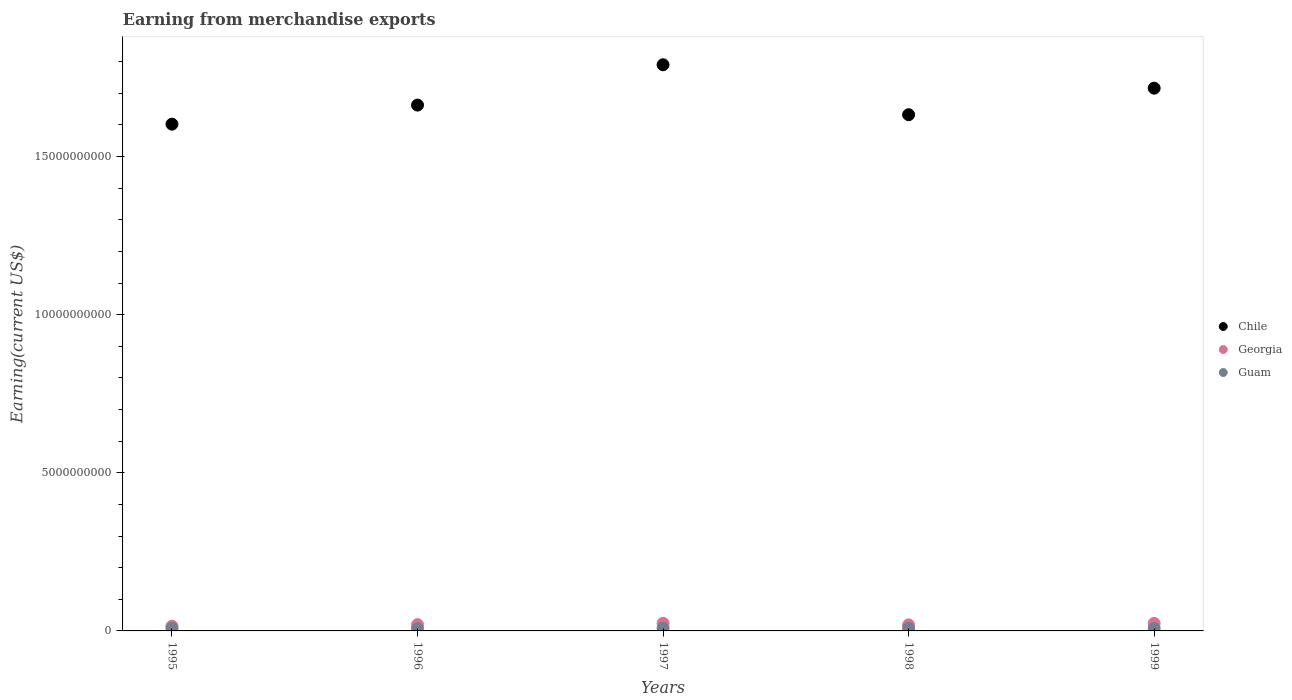What is the amount earned from merchandise exports in Georgia in 1997?
Offer a terse response. 2.40e+08. Across all years, what is the maximum amount earned from merchandise exports in Georgia?
Your answer should be compact. 2.40e+08. Across all years, what is the minimum amount earned from merchandise exports in Guam?
Offer a terse response. 7.32e+07. In which year was the amount earned from merchandise exports in Chile maximum?
Offer a very short reply. 1997. In which year was the amount earned from merchandise exports in Guam minimum?
Provide a short and direct response. 1996. What is the total amount earned from merchandise exports in Chile in the graph?
Give a very brief answer. 8.40e+1. What is the difference between the amount earned from merchandise exports in Chile in 1995 and that in 1999?
Your response must be concise. -1.14e+09. What is the difference between the amount earned from merchandise exports in Guam in 1995 and the amount earned from merchandise exports in Georgia in 1996?
Provide a short and direct response. -1.14e+08. What is the average amount earned from merchandise exports in Georgia per year?
Give a very brief answer. 2.04e+08. In the year 1997, what is the difference between the amount earned from merchandise exports in Guam and amount earned from merchandise exports in Chile?
Make the answer very short. -1.78e+1. In how many years, is the amount earned from merchandise exports in Chile greater than 4000000000 US$?
Provide a short and direct response. 5. What is the ratio of the amount earned from merchandise exports in Chile in 1996 to that in 1997?
Your answer should be very brief. 0.93. What is the difference between the highest and the second highest amount earned from merchandise exports in Guam?
Your answer should be compact. 2.70e+06. What is the difference between the highest and the lowest amount earned from merchandise exports in Guam?
Your response must be concise. 1.55e+07. In how many years, is the amount earned from merchandise exports in Chile greater than the average amount earned from merchandise exports in Chile taken over all years?
Give a very brief answer. 2. Is the sum of the amount earned from merchandise exports in Georgia in 1997 and 1998 greater than the maximum amount earned from merchandise exports in Guam across all years?
Ensure brevity in your answer.  Yes. Is it the case that in every year, the sum of the amount earned from merchandise exports in Georgia and amount earned from merchandise exports in Chile  is greater than the amount earned from merchandise exports in Guam?
Give a very brief answer. Yes. How many years are there in the graph?
Your response must be concise. 5. What is the difference between two consecutive major ticks on the Y-axis?
Offer a terse response. 5.00e+09. Does the graph contain any zero values?
Keep it short and to the point. No. Does the graph contain grids?
Keep it short and to the point. No. How are the legend labels stacked?
Keep it short and to the point. Vertical. What is the title of the graph?
Your answer should be compact. Earning from merchandise exports. Does "Montenegro" appear as one of the legend labels in the graph?
Ensure brevity in your answer.  No. What is the label or title of the Y-axis?
Your response must be concise. Earning(current US$). What is the Earning(current US$) of Chile in 1995?
Make the answer very short. 1.60e+1. What is the Earning(current US$) of Georgia in 1995?
Offer a terse response. 1.51e+08. What is the Earning(current US$) in Guam in 1995?
Your answer should be compact. 8.50e+07. What is the Earning(current US$) of Chile in 1996?
Provide a succinct answer. 1.66e+1. What is the Earning(current US$) in Georgia in 1996?
Provide a short and direct response. 1.99e+08. What is the Earning(current US$) of Guam in 1996?
Provide a short and direct response. 7.32e+07. What is the Earning(current US$) of Chile in 1997?
Make the answer very short. 1.79e+1. What is the Earning(current US$) in Georgia in 1997?
Make the answer very short. 2.40e+08. What is the Earning(current US$) in Guam in 1997?
Provide a short and direct response. 8.87e+07. What is the Earning(current US$) in Chile in 1998?
Offer a very short reply. 1.63e+1. What is the Earning(current US$) in Georgia in 1998?
Your response must be concise. 1.91e+08. What is the Earning(current US$) of Guam in 1998?
Provide a short and direct response. 8.60e+07. What is the Earning(current US$) in Chile in 1999?
Make the answer very short. 1.72e+1. What is the Earning(current US$) of Georgia in 1999?
Your answer should be very brief. 2.38e+08. What is the Earning(current US$) in Guam in 1999?
Make the answer very short. 7.60e+07. Across all years, what is the maximum Earning(current US$) in Chile?
Your response must be concise. 1.79e+1. Across all years, what is the maximum Earning(current US$) of Georgia?
Keep it short and to the point. 2.40e+08. Across all years, what is the maximum Earning(current US$) in Guam?
Offer a terse response. 8.87e+07. Across all years, what is the minimum Earning(current US$) of Chile?
Give a very brief answer. 1.60e+1. Across all years, what is the minimum Earning(current US$) of Georgia?
Your answer should be very brief. 1.51e+08. Across all years, what is the minimum Earning(current US$) in Guam?
Keep it short and to the point. 7.32e+07. What is the total Earning(current US$) of Chile in the graph?
Make the answer very short. 8.40e+1. What is the total Earning(current US$) of Georgia in the graph?
Ensure brevity in your answer.  1.02e+09. What is the total Earning(current US$) in Guam in the graph?
Offer a very short reply. 4.09e+08. What is the difference between the Earning(current US$) of Chile in 1995 and that in 1996?
Provide a short and direct response. -6.03e+08. What is the difference between the Earning(current US$) in Georgia in 1995 and that in 1996?
Your answer should be compact. -4.80e+07. What is the difference between the Earning(current US$) of Guam in 1995 and that in 1996?
Make the answer very short. 1.18e+07. What is the difference between the Earning(current US$) of Chile in 1995 and that in 1997?
Provide a succinct answer. -1.88e+09. What is the difference between the Earning(current US$) of Georgia in 1995 and that in 1997?
Your answer should be very brief. -8.90e+07. What is the difference between the Earning(current US$) in Guam in 1995 and that in 1997?
Offer a very short reply. -3.71e+06. What is the difference between the Earning(current US$) in Chile in 1995 and that in 1998?
Provide a succinct answer. -2.99e+08. What is the difference between the Earning(current US$) of Georgia in 1995 and that in 1998?
Give a very brief answer. -4.00e+07. What is the difference between the Earning(current US$) of Guam in 1995 and that in 1998?
Your answer should be very brief. -1.01e+06. What is the difference between the Earning(current US$) in Chile in 1995 and that in 1999?
Make the answer very short. -1.14e+09. What is the difference between the Earning(current US$) in Georgia in 1995 and that in 1999?
Make the answer very short. -8.70e+07. What is the difference between the Earning(current US$) of Guam in 1995 and that in 1999?
Your answer should be very brief. 8.99e+06. What is the difference between the Earning(current US$) of Chile in 1996 and that in 1997?
Your answer should be very brief. -1.28e+09. What is the difference between the Earning(current US$) of Georgia in 1996 and that in 1997?
Your response must be concise. -4.10e+07. What is the difference between the Earning(current US$) in Guam in 1996 and that in 1997?
Provide a succinct answer. -1.55e+07. What is the difference between the Earning(current US$) of Chile in 1996 and that in 1998?
Give a very brief answer. 3.04e+08. What is the difference between the Earning(current US$) in Georgia in 1996 and that in 1998?
Make the answer very short. 8.00e+06. What is the difference between the Earning(current US$) of Guam in 1996 and that in 1998?
Ensure brevity in your answer.  -1.28e+07. What is the difference between the Earning(current US$) in Chile in 1996 and that in 1999?
Your response must be concise. -5.35e+08. What is the difference between the Earning(current US$) of Georgia in 1996 and that in 1999?
Make the answer very short. -3.90e+07. What is the difference between the Earning(current US$) of Guam in 1996 and that in 1999?
Keep it short and to the point. -2.83e+06. What is the difference between the Earning(current US$) in Chile in 1997 and that in 1998?
Ensure brevity in your answer.  1.58e+09. What is the difference between the Earning(current US$) of Georgia in 1997 and that in 1998?
Ensure brevity in your answer.  4.90e+07. What is the difference between the Earning(current US$) in Guam in 1997 and that in 1998?
Keep it short and to the point. 2.70e+06. What is the difference between the Earning(current US$) in Chile in 1997 and that in 1999?
Offer a very short reply. 7.40e+08. What is the difference between the Earning(current US$) in Georgia in 1997 and that in 1999?
Your answer should be very brief. 2.00e+06. What is the difference between the Earning(current US$) of Guam in 1997 and that in 1999?
Give a very brief answer. 1.27e+07. What is the difference between the Earning(current US$) in Chile in 1998 and that in 1999?
Provide a succinct answer. -8.39e+08. What is the difference between the Earning(current US$) in Georgia in 1998 and that in 1999?
Keep it short and to the point. -4.70e+07. What is the difference between the Earning(current US$) of Guam in 1998 and that in 1999?
Your response must be concise. 1.00e+07. What is the difference between the Earning(current US$) in Chile in 1995 and the Earning(current US$) in Georgia in 1996?
Your answer should be very brief. 1.58e+1. What is the difference between the Earning(current US$) of Chile in 1995 and the Earning(current US$) of Guam in 1996?
Ensure brevity in your answer.  1.60e+1. What is the difference between the Earning(current US$) in Georgia in 1995 and the Earning(current US$) in Guam in 1996?
Keep it short and to the point. 7.78e+07. What is the difference between the Earning(current US$) of Chile in 1995 and the Earning(current US$) of Georgia in 1997?
Ensure brevity in your answer.  1.58e+1. What is the difference between the Earning(current US$) in Chile in 1995 and the Earning(current US$) in Guam in 1997?
Keep it short and to the point. 1.59e+1. What is the difference between the Earning(current US$) in Georgia in 1995 and the Earning(current US$) in Guam in 1997?
Offer a terse response. 6.23e+07. What is the difference between the Earning(current US$) of Chile in 1995 and the Earning(current US$) of Georgia in 1998?
Your answer should be very brief. 1.58e+1. What is the difference between the Earning(current US$) of Chile in 1995 and the Earning(current US$) of Guam in 1998?
Ensure brevity in your answer.  1.59e+1. What is the difference between the Earning(current US$) of Georgia in 1995 and the Earning(current US$) of Guam in 1998?
Provide a short and direct response. 6.50e+07. What is the difference between the Earning(current US$) in Chile in 1995 and the Earning(current US$) in Georgia in 1999?
Make the answer very short. 1.58e+1. What is the difference between the Earning(current US$) in Chile in 1995 and the Earning(current US$) in Guam in 1999?
Offer a very short reply. 1.59e+1. What is the difference between the Earning(current US$) in Georgia in 1995 and the Earning(current US$) in Guam in 1999?
Your answer should be compact. 7.50e+07. What is the difference between the Earning(current US$) in Chile in 1996 and the Earning(current US$) in Georgia in 1997?
Keep it short and to the point. 1.64e+1. What is the difference between the Earning(current US$) in Chile in 1996 and the Earning(current US$) in Guam in 1997?
Your response must be concise. 1.65e+1. What is the difference between the Earning(current US$) in Georgia in 1996 and the Earning(current US$) in Guam in 1997?
Make the answer very short. 1.10e+08. What is the difference between the Earning(current US$) in Chile in 1996 and the Earning(current US$) in Georgia in 1998?
Make the answer very short. 1.64e+1. What is the difference between the Earning(current US$) of Chile in 1996 and the Earning(current US$) of Guam in 1998?
Provide a succinct answer. 1.65e+1. What is the difference between the Earning(current US$) in Georgia in 1996 and the Earning(current US$) in Guam in 1998?
Provide a succinct answer. 1.13e+08. What is the difference between the Earning(current US$) in Chile in 1996 and the Earning(current US$) in Georgia in 1999?
Ensure brevity in your answer.  1.64e+1. What is the difference between the Earning(current US$) of Chile in 1996 and the Earning(current US$) of Guam in 1999?
Your response must be concise. 1.66e+1. What is the difference between the Earning(current US$) in Georgia in 1996 and the Earning(current US$) in Guam in 1999?
Keep it short and to the point. 1.23e+08. What is the difference between the Earning(current US$) in Chile in 1997 and the Earning(current US$) in Georgia in 1998?
Give a very brief answer. 1.77e+1. What is the difference between the Earning(current US$) of Chile in 1997 and the Earning(current US$) of Guam in 1998?
Provide a short and direct response. 1.78e+1. What is the difference between the Earning(current US$) in Georgia in 1997 and the Earning(current US$) in Guam in 1998?
Your answer should be compact. 1.54e+08. What is the difference between the Earning(current US$) in Chile in 1997 and the Earning(current US$) in Georgia in 1999?
Give a very brief answer. 1.77e+1. What is the difference between the Earning(current US$) in Chile in 1997 and the Earning(current US$) in Guam in 1999?
Provide a succinct answer. 1.78e+1. What is the difference between the Earning(current US$) of Georgia in 1997 and the Earning(current US$) of Guam in 1999?
Your answer should be very brief. 1.64e+08. What is the difference between the Earning(current US$) in Chile in 1998 and the Earning(current US$) in Georgia in 1999?
Offer a very short reply. 1.61e+1. What is the difference between the Earning(current US$) in Chile in 1998 and the Earning(current US$) in Guam in 1999?
Provide a short and direct response. 1.62e+1. What is the difference between the Earning(current US$) in Georgia in 1998 and the Earning(current US$) in Guam in 1999?
Your response must be concise. 1.15e+08. What is the average Earning(current US$) in Chile per year?
Provide a succinct answer. 1.68e+1. What is the average Earning(current US$) in Georgia per year?
Your response must be concise. 2.04e+08. What is the average Earning(current US$) in Guam per year?
Give a very brief answer. 8.18e+07. In the year 1995, what is the difference between the Earning(current US$) in Chile and Earning(current US$) in Georgia?
Keep it short and to the point. 1.59e+1. In the year 1995, what is the difference between the Earning(current US$) in Chile and Earning(current US$) in Guam?
Keep it short and to the point. 1.59e+1. In the year 1995, what is the difference between the Earning(current US$) in Georgia and Earning(current US$) in Guam?
Offer a very short reply. 6.60e+07. In the year 1996, what is the difference between the Earning(current US$) of Chile and Earning(current US$) of Georgia?
Provide a succinct answer. 1.64e+1. In the year 1996, what is the difference between the Earning(current US$) of Chile and Earning(current US$) of Guam?
Ensure brevity in your answer.  1.66e+1. In the year 1996, what is the difference between the Earning(current US$) of Georgia and Earning(current US$) of Guam?
Your answer should be very brief. 1.26e+08. In the year 1997, what is the difference between the Earning(current US$) in Chile and Earning(current US$) in Georgia?
Your answer should be very brief. 1.77e+1. In the year 1997, what is the difference between the Earning(current US$) of Chile and Earning(current US$) of Guam?
Provide a succinct answer. 1.78e+1. In the year 1997, what is the difference between the Earning(current US$) of Georgia and Earning(current US$) of Guam?
Your answer should be compact. 1.51e+08. In the year 1998, what is the difference between the Earning(current US$) in Chile and Earning(current US$) in Georgia?
Your response must be concise. 1.61e+1. In the year 1998, what is the difference between the Earning(current US$) of Chile and Earning(current US$) of Guam?
Offer a terse response. 1.62e+1. In the year 1998, what is the difference between the Earning(current US$) of Georgia and Earning(current US$) of Guam?
Your answer should be very brief. 1.05e+08. In the year 1999, what is the difference between the Earning(current US$) of Chile and Earning(current US$) of Georgia?
Your response must be concise. 1.69e+1. In the year 1999, what is the difference between the Earning(current US$) of Chile and Earning(current US$) of Guam?
Provide a short and direct response. 1.71e+1. In the year 1999, what is the difference between the Earning(current US$) in Georgia and Earning(current US$) in Guam?
Your response must be concise. 1.62e+08. What is the ratio of the Earning(current US$) of Chile in 1995 to that in 1996?
Your answer should be compact. 0.96. What is the ratio of the Earning(current US$) in Georgia in 1995 to that in 1996?
Provide a succinct answer. 0.76. What is the ratio of the Earning(current US$) in Guam in 1995 to that in 1996?
Your response must be concise. 1.16. What is the ratio of the Earning(current US$) in Chile in 1995 to that in 1997?
Ensure brevity in your answer.  0.9. What is the ratio of the Earning(current US$) of Georgia in 1995 to that in 1997?
Your answer should be compact. 0.63. What is the ratio of the Earning(current US$) of Guam in 1995 to that in 1997?
Offer a very short reply. 0.96. What is the ratio of the Earning(current US$) in Chile in 1995 to that in 1998?
Make the answer very short. 0.98. What is the ratio of the Earning(current US$) in Georgia in 1995 to that in 1998?
Provide a succinct answer. 0.79. What is the ratio of the Earning(current US$) in Chile in 1995 to that in 1999?
Give a very brief answer. 0.93. What is the ratio of the Earning(current US$) of Georgia in 1995 to that in 1999?
Keep it short and to the point. 0.63. What is the ratio of the Earning(current US$) of Guam in 1995 to that in 1999?
Offer a very short reply. 1.12. What is the ratio of the Earning(current US$) of Chile in 1996 to that in 1997?
Keep it short and to the point. 0.93. What is the ratio of the Earning(current US$) in Georgia in 1996 to that in 1997?
Ensure brevity in your answer.  0.83. What is the ratio of the Earning(current US$) in Guam in 1996 to that in 1997?
Offer a very short reply. 0.82. What is the ratio of the Earning(current US$) in Chile in 1996 to that in 1998?
Offer a terse response. 1.02. What is the ratio of the Earning(current US$) of Georgia in 1996 to that in 1998?
Offer a very short reply. 1.04. What is the ratio of the Earning(current US$) in Guam in 1996 to that in 1998?
Make the answer very short. 0.85. What is the ratio of the Earning(current US$) of Chile in 1996 to that in 1999?
Your response must be concise. 0.97. What is the ratio of the Earning(current US$) in Georgia in 1996 to that in 1999?
Make the answer very short. 0.84. What is the ratio of the Earning(current US$) in Guam in 1996 to that in 1999?
Keep it short and to the point. 0.96. What is the ratio of the Earning(current US$) of Chile in 1997 to that in 1998?
Provide a short and direct response. 1.1. What is the ratio of the Earning(current US$) of Georgia in 1997 to that in 1998?
Your answer should be compact. 1.26. What is the ratio of the Earning(current US$) of Guam in 1997 to that in 1998?
Your answer should be very brief. 1.03. What is the ratio of the Earning(current US$) of Chile in 1997 to that in 1999?
Give a very brief answer. 1.04. What is the ratio of the Earning(current US$) in Georgia in 1997 to that in 1999?
Provide a succinct answer. 1.01. What is the ratio of the Earning(current US$) of Guam in 1997 to that in 1999?
Keep it short and to the point. 1.17. What is the ratio of the Earning(current US$) in Chile in 1998 to that in 1999?
Give a very brief answer. 0.95. What is the ratio of the Earning(current US$) in Georgia in 1998 to that in 1999?
Your response must be concise. 0.8. What is the ratio of the Earning(current US$) of Guam in 1998 to that in 1999?
Offer a terse response. 1.13. What is the difference between the highest and the second highest Earning(current US$) in Chile?
Your answer should be compact. 7.40e+08. What is the difference between the highest and the second highest Earning(current US$) of Guam?
Your answer should be very brief. 2.70e+06. What is the difference between the highest and the lowest Earning(current US$) in Chile?
Ensure brevity in your answer.  1.88e+09. What is the difference between the highest and the lowest Earning(current US$) in Georgia?
Give a very brief answer. 8.90e+07. What is the difference between the highest and the lowest Earning(current US$) in Guam?
Your response must be concise. 1.55e+07. 